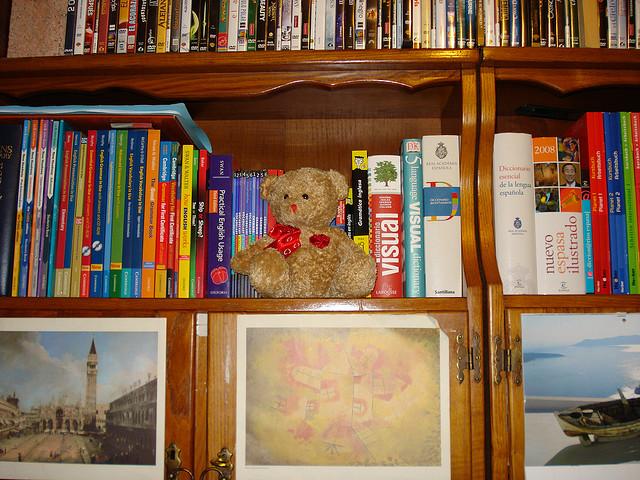Is there a green vase in this picture?
Short answer required. No. Is the picture on the left of a zoo?
Quick response, please. No. What type of intellect are books like the yellow and black one behind the bear geared towards?
Quick response, please. Dummies. Are the books neatly arranged?
Give a very brief answer. Yes. How many books are there?
Write a very short answer. 25. What is in the picture?
Be succinct. Books. What is the teddy bear sitting on?
Keep it brief. Shelf. 